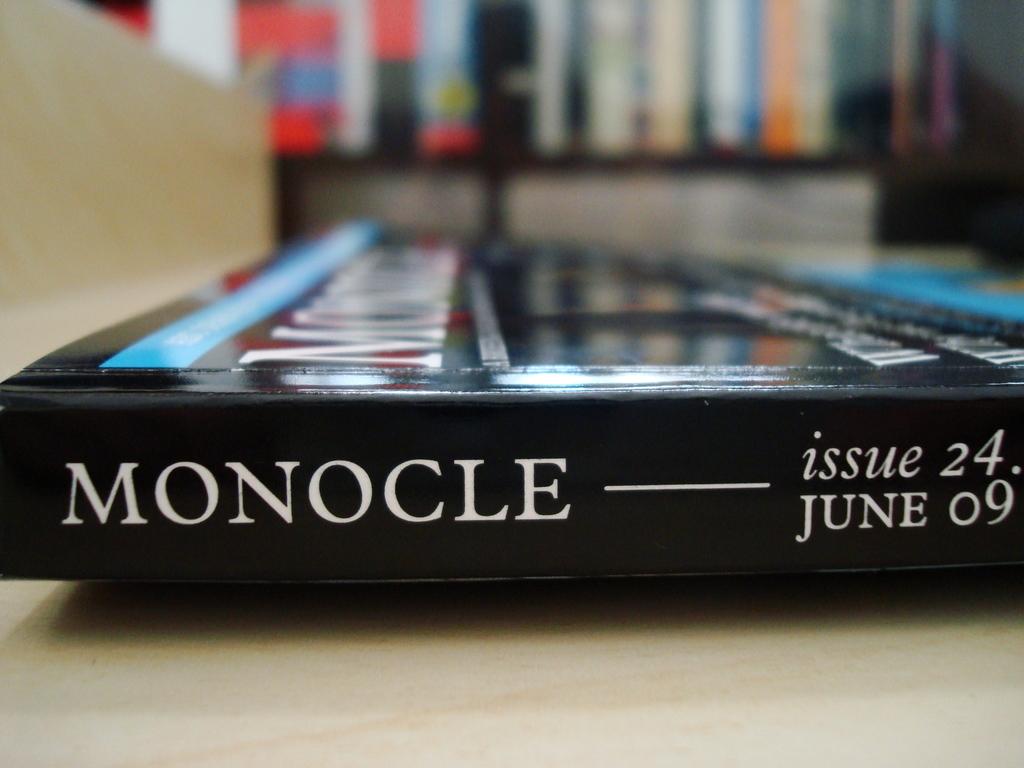What is the title of the book?
Your answer should be compact. Monocle. What issue number?
Ensure brevity in your answer.  24. 